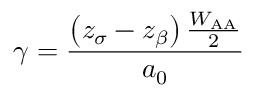Convert formula to latex. <formula><loc_0><loc_0><loc_500><loc_500>\gamma = { \frac { \left ( z _ { \sigma } - z _ { \beta } \right ) { \frac { W _ { A A } } { 2 } } } { a _ { 0 } } }</formula> 